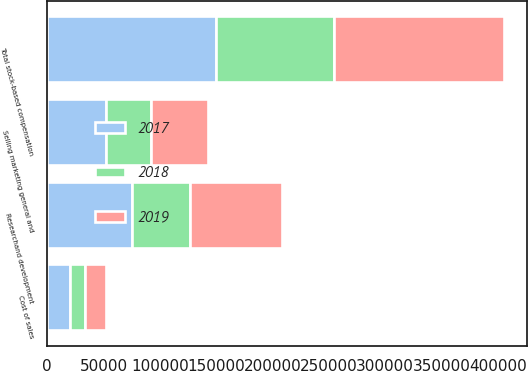Convert chart. <chart><loc_0><loc_0><loc_500><loc_500><stacked_bar_chart><ecel><fcel>Cost of sales<fcel>Researchand development<fcel>Selling marketing general and<fcel>Total stock-based compensation<nl><fcel>2017<fcel>20628<fcel>75305<fcel>51829<fcel>150300<nl><fcel>2019<fcel>18733<fcel>81444<fcel>50988<fcel>151165<nl><fcel>2018<fcel>12569<fcel>51258<fcel>40361<fcel>104188<nl></chart> 